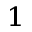Convert formula to latex. <formula><loc_0><loc_0><loc_500><loc_500>^ { 1 }</formula> 